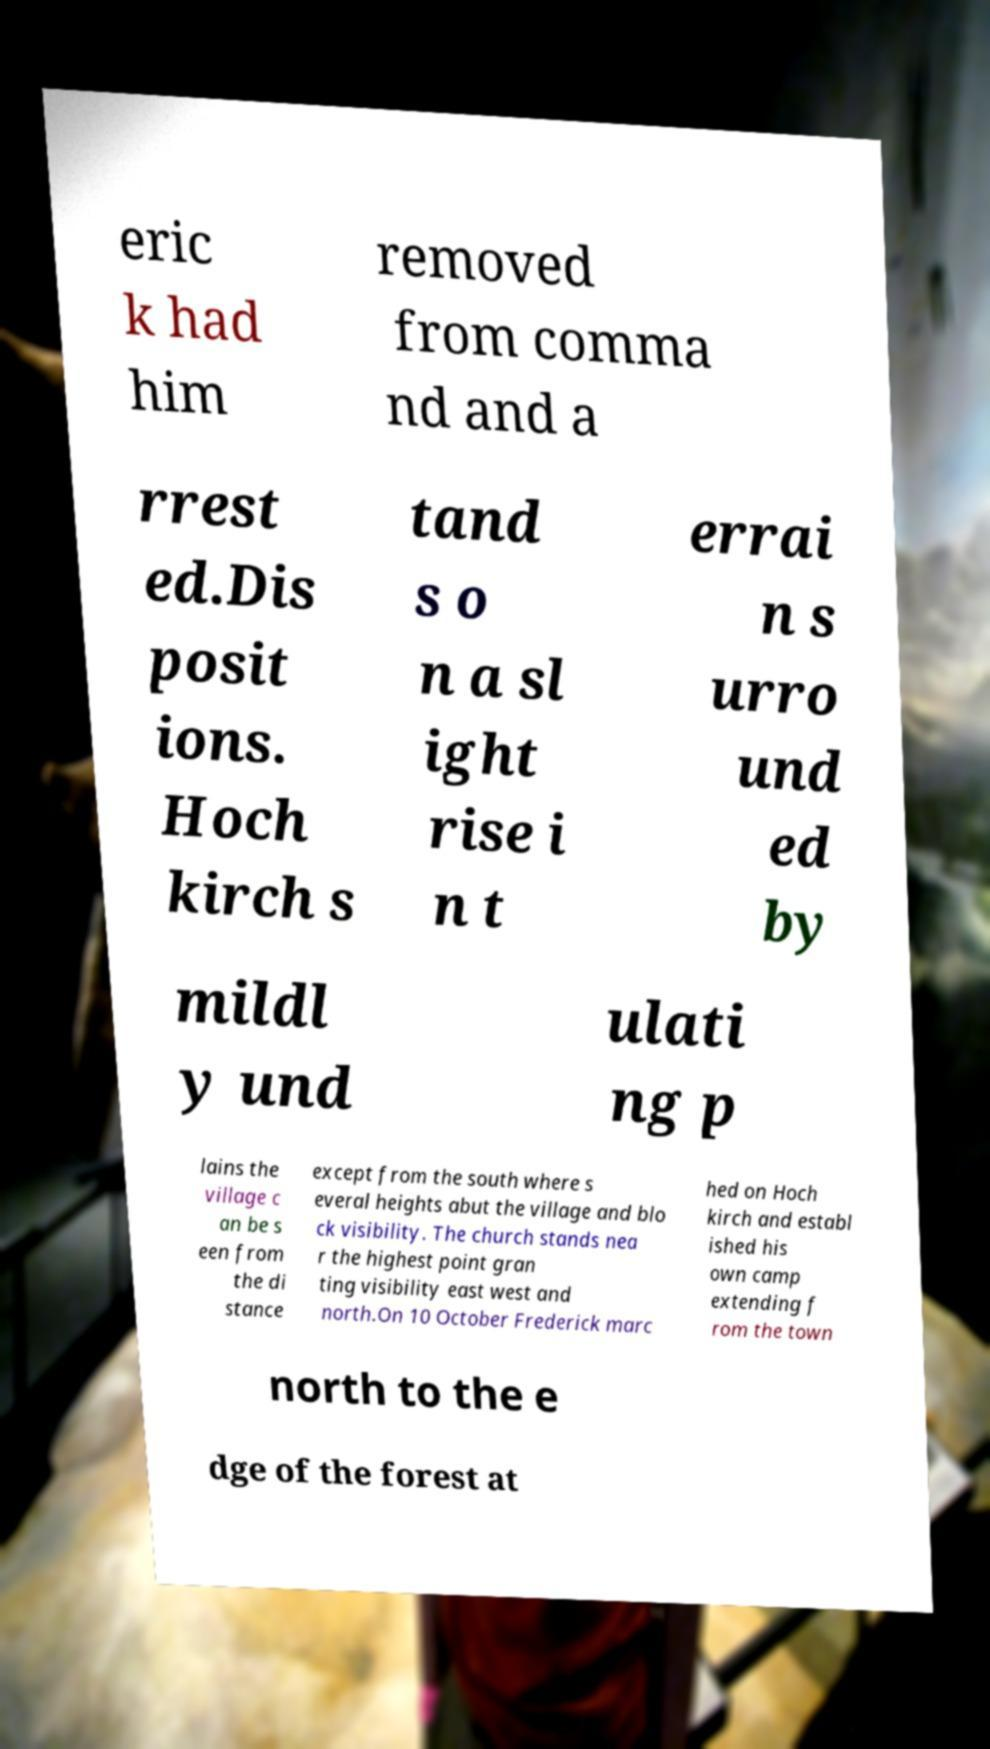Please identify and transcribe the text found in this image. eric k had him removed from comma nd and a rrest ed.Dis posit ions. Hoch kirch s tand s o n a sl ight rise i n t errai n s urro und ed by mildl y und ulati ng p lains the village c an be s een from the di stance except from the south where s everal heights abut the village and blo ck visibility. The church stands nea r the highest point gran ting visibility east west and north.On 10 October Frederick marc hed on Hoch kirch and establ ished his own camp extending f rom the town north to the e dge of the forest at 